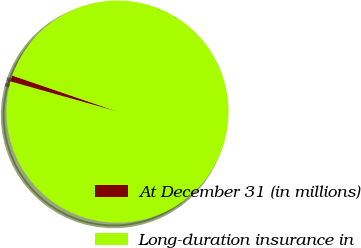<chart> <loc_0><loc_0><loc_500><loc_500><pie_chart><fcel>At December 31 (in millions)<fcel>Long-duration insurance in<nl><fcel>0.87%<fcel>99.13%<nl></chart> 